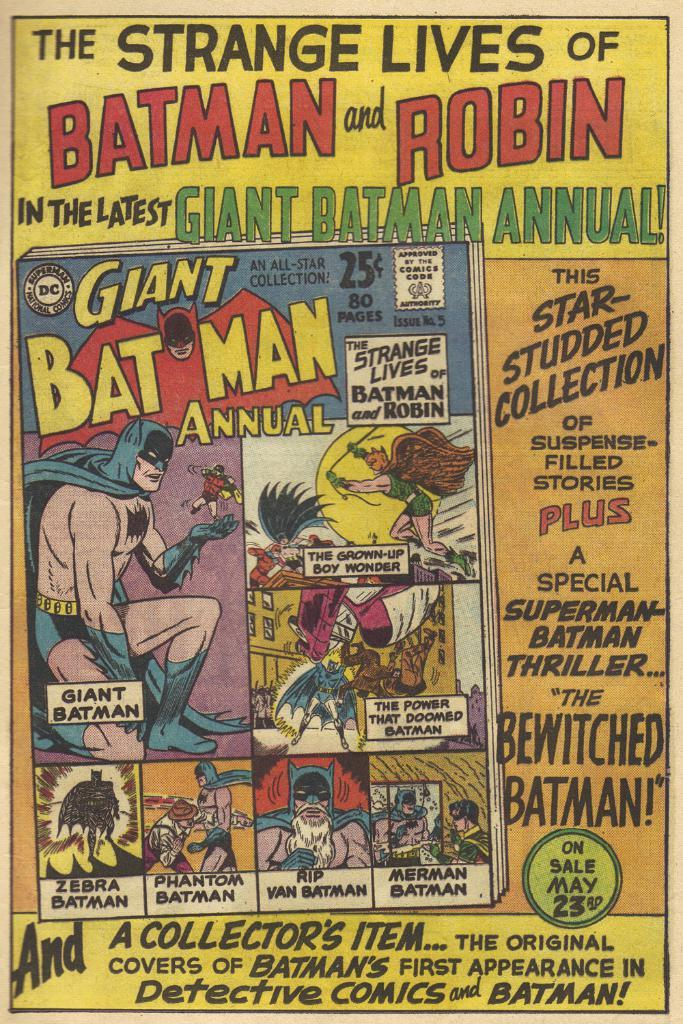<image>
Present a compact description of the photo's key features. The Strange Lives of Batman and Robincomic book was a collector's item then and now. 